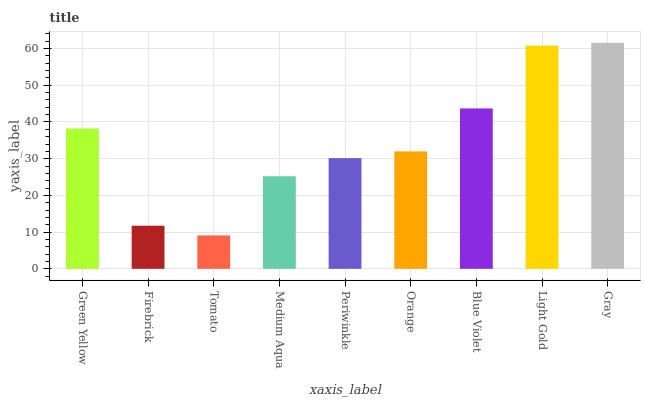Is Tomato the minimum?
Answer yes or no. Yes. Is Gray the maximum?
Answer yes or no. Yes. Is Firebrick the minimum?
Answer yes or no. No. Is Firebrick the maximum?
Answer yes or no. No. Is Green Yellow greater than Firebrick?
Answer yes or no. Yes. Is Firebrick less than Green Yellow?
Answer yes or no. Yes. Is Firebrick greater than Green Yellow?
Answer yes or no. No. Is Green Yellow less than Firebrick?
Answer yes or no. No. Is Orange the high median?
Answer yes or no. Yes. Is Orange the low median?
Answer yes or no. Yes. Is Periwinkle the high median?
Answer yes or no. No. Is Firebrick the low median?
Answer yes or no. No. 